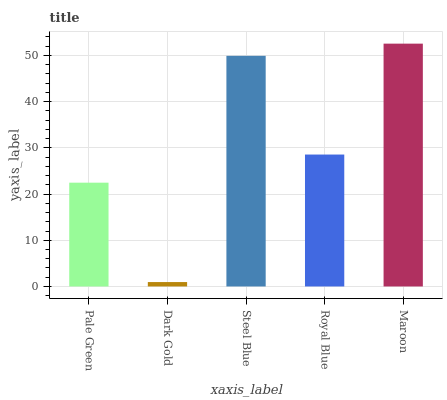Is Steel Blue the minimum?
Answer yes or no. No. Is Steel Blue the maximum?
Answer yes or no. No. Is Steel Blue greater than Dark Gold?
Answer yes or no. Yes. Is Dark Gold less than Steel Blue?
Answer yes or no. Yes. Is Dark Gold greater than Steel Blue?
Answer yes or no. No. Is Steel Blue less than Dark Gold?
Answer yes or no. No. Is Royal Blue the high median?
Answer yes or no. Yes. Is Royal Blue the low median?
Answer yes or no. Yes. Is Pale Green the high median?
Answer yes or no. No. Is Steel Blue the low median?
Answer yes or no. No. 